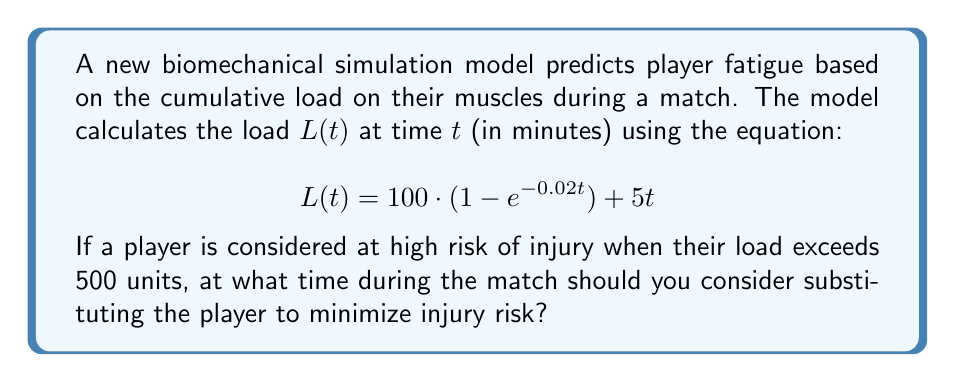Teach me how to tackle this problem. To solve this problem, we need to find the time $t$ when the load $L(t)$ reaches 500 units. Let's approach this step-by-step:

1) We start with the equation:
   $$L(t) = 100 \cdot (1 - e^{-0.02t}) + 5t$$

2) We want to find $t$ when $L(t) = 500$. So, we set up the equation:
   $$500 = 100 \cdot (1 - e^{-0.02t}) + 5t$$

3) Rearranging the equation:
   $$400 = 100 \cdot (1 - e^{-0.02t}) + 5t$$
   $$400 - 5t = 100 \cdot (1 - e^{-0.02t})$$
   $$4 - 0.05t = 1 - e^{-0.02t}$$
   $$e^{-0.02t} = 5 - 0.05t$$

4) Taking the natural log of both sides:
   $$-0.02t = \ln(5 - 0.05t)$$

5) This equation cannot be solved algebraically. We need to use numerical methods or graphical solutions.

6) Using a graphing calculator or computer software, we can find that the solution is approximately:
   $$t \approx 66.7$$

7) Since we're dealing with minutes in a football match, we should round this to the nearest minute:
   $$t \approx 67$$

Therefore, you should consider substituting the player at around the 67th minute of the match to minimize injury risk.
Answer: 67 minutes 